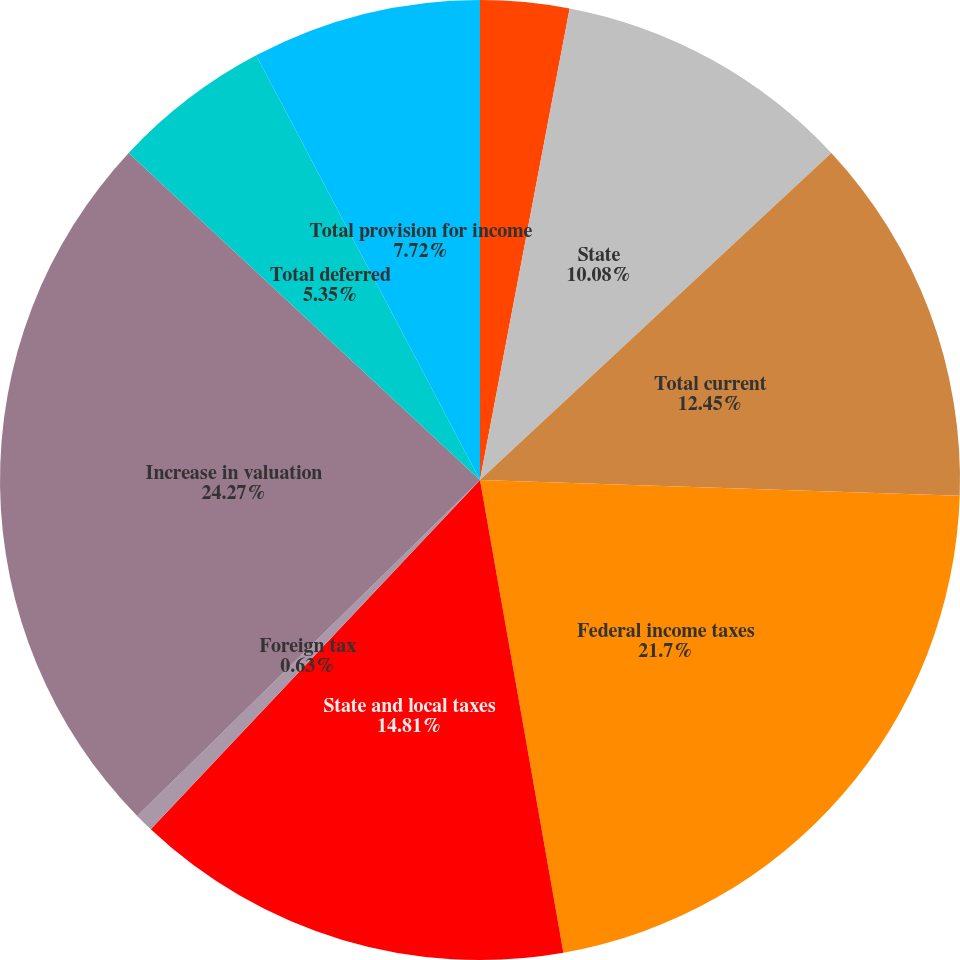Convert chart to OTSL. <chart><loc_0><loc_0><loc_500><loc_500><pie_chart><fcel>Foreign<fcel>State<fcel>Total current<fcel>Federal income taxes<fcel>State and local taxes<fcel>Foreign tax<fcel>Increase in valuation<fcel>Total deferred<fcel>Total provision for income<nl><fcel>2.99%<fcel>10.08%<fcel>12.45%<fcel>21.7%<fcel>14.81%<fcel>0.63%<fcel>24.27%<fcel>5.35%<fcel>7.72%<nl></chart> 